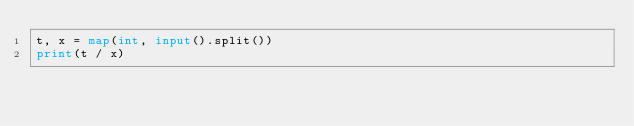<code> <loc_0><loc_0><loc_500><loc_500><_Python_>t, x = map(int, input().split())
print(t / x)
</code> 